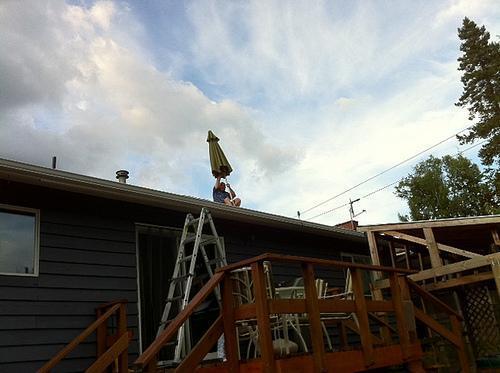How many people are on the roof?
Give a very brief answer. 1. 